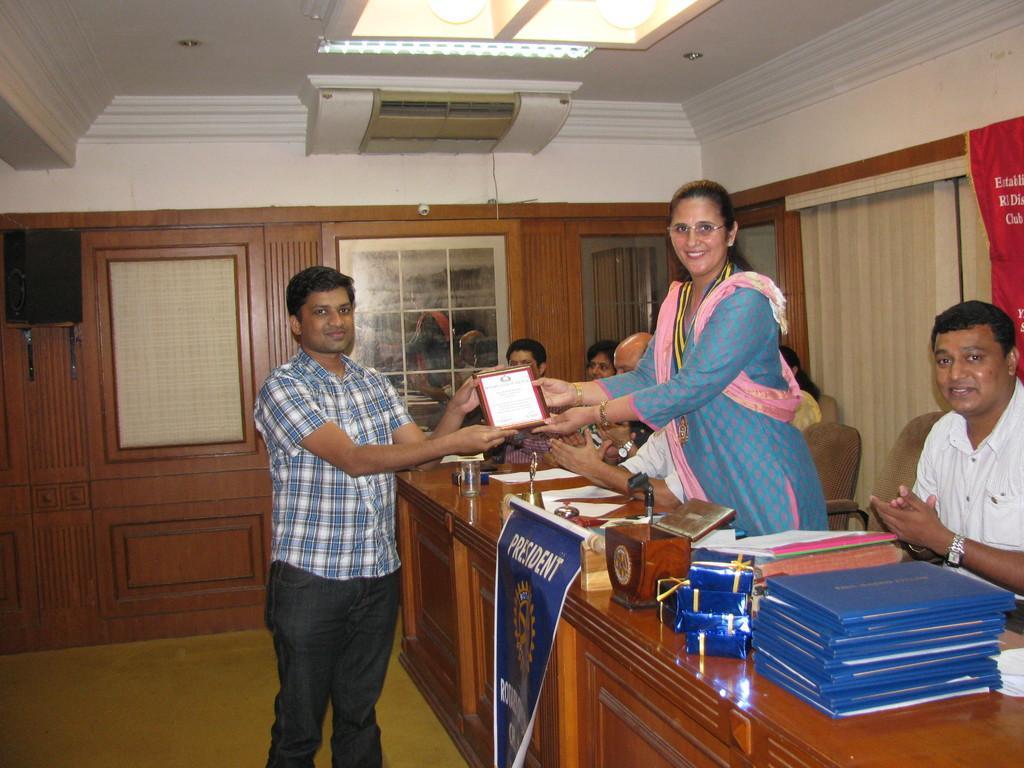Describe this image in one or two sentences. In this image we can see a man and a woman standing holding a frame. We can also see some people sitting on the chairs beside a table containing some files, gift boxes, board, books, stand and some papers. On the backside we can see a door, windows, wall, curtains, roof and a ceiling light. 